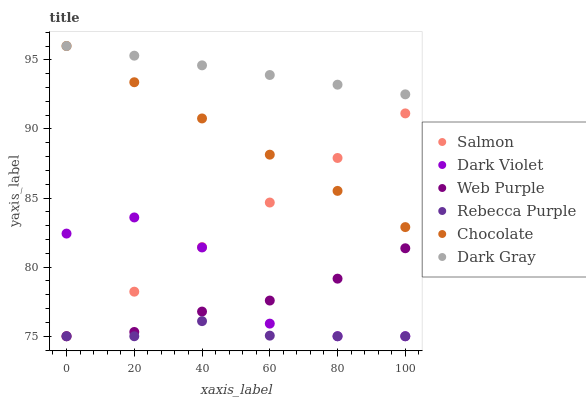Does Rebecca Purple have the minimum area under the curve?
Answer yes or no. Yes. Does Dark Gray have the maximum area under the curve?
Answer yes or no. Yes. Does Dark Violet have the minimum area under the curve?
Answer yes or no. No. Does Dark Violet have the maximum area under the curve?
Answer yes or no. No. Is Salmon the smoothest?
Answer yes or no. Yes. Is Dark Violet the roughest?
Answer yes or no. Yes. Is Chocolate the smoothest?
Answer yes or no. No. Is Chocolate the roughest?
Answer yes or no. No. Does Salmon have the lowest value?
Answer yes or no. Yes. Does Chocolate have the lowest value?
Answer yes or no. No. Does Dark Gray have the highest value?
Answer yes or no. Yes. Does Dark Violet have the highest value?
Answer yes or no. No. Is Web Purple less than Dark Gray?
Answer yes or no. Yes. Is Dark Gray greater than Dark Violet?
Answer yes or no. Yes. Does Dark Violet intersect Salmon?
Answer yes or no. Yes. Is Dark Violet less than Salmon?
Answer yes or no. No. Is Dark Violet greater than Salmon?
Answer yes or no. No. Does Web Purple intersect Dark Gray?
Answer yes or no. No. 